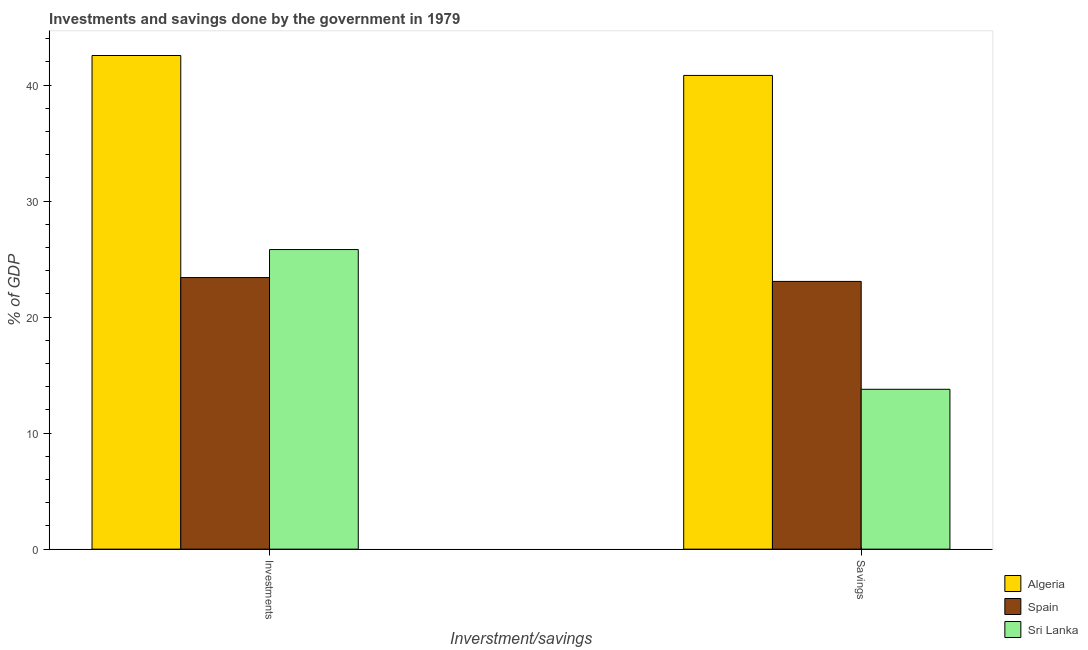How many different coloured bars are there?
Your answer should be very brief. 3. Are the number of bars per tick equal to the number of legend labels?
Offer a very short reply. Yes. How many bars are there on the 2nd tick from the left?
Make the answer very short. 3. What is the label of the 2nd group of bars from the left?
Make the answer very short. Savings. What is the investments of government in Spain?
Make the answer very short. 23.41. Across all countries, what is the maximum savings of government?
Your answer should be very brief. 40.83. Across all countries, what is the minimum savings of government?
Offer a very short reply. 13.78. In which country was the savings of government maximum?
Offer a very short reply. Algeria. In which country was the savings of government minimum?
Provide a short and direct response. Sri Lanka. What is the total savings of government in the graph?
Offer a terse response. 77.68. What is the difference between the savings of government in Spain and that in Algeria?
Give a very brief answer. -17.75. What is the difference between the savings of government in Sri Lanka and the investments of government in Spain?
Provide a short and direct response. -9.63. What is the average investments of government per country?
Offer a very short reply. 30.59. What is the difference between the investments of government and savings of government in Sri Lanka?
Give a very brief answer. 12.04. What is the ratio of the investments of government in Spain to that in Algeria?
Ensure brevity in your answer.  0.55. Is the savings of government in Sri Lanka less than that in Algeria?
Your answer should be very brief. Yes. What does the 3rd bar from the left in Investments represents?
Give a very brief answer. Sri Lanka. What does the 1st bar from the right in Savings represents?
Make the answer very short. Sri Lanka. How many countries are there in the graph?
Offer a very short reply. 3. Are the values on the major ticks of Y-axis written in scientific E-notation?
Keep it short and to the point. No. Does the graph contain grids?
Provide a succinct answer. No. Where does the legend appear in the graph?
Ensure brevity in your answer.  Bottom right. What is the title of the graph?
Your answer should be very brief. Investments and savings done by the government in 1979. What is the label or title of the X-axis?
Your answer should be compact. Inverstment/savings. What is the label or title of the Y-axis?
Keep it short and to the point. % of GDP. What is the % of GDP in Algeria in Investments?
Offer a very short reply. 42.55. What is the % of GDP in Spain in Investments?
Your answer should be compact. 23.41. What is the % of GDP in Sri Lanka in Investments?
Make the answer very short. 25.82. What is the % of GDP of Algeria in Savings?
Your answer should be compact. 40.83. What is the % of GDP of Spain in Savings?
Give a very brief answer. 23.08. What is the % of GDP in Sri Lanka in Savings?
Provide a short and direct response. 13.78. Across all Inverstment/savings, what is the maximum % of GDP in Algeria?
Provide a succinct answer. 42.55. Across all Inverstment/savings, what is the maximum % of GDP in Spain?
Offer a very short reply. 23.41. Across all Inverstment/savings, what is the maximum % of GDP of Sri Lanka?
Provide a short and direct response. 25.82. Across all Inverstment/savings, what is the minimum % of GDP in Algeria?
Your response must be concise. 40.83. Across all Inverstment/savings, what is the minimum % of GDP in Spain?
Offer a terse response. 23.08. Across all Inverstment/savings, what is the minimum % of GDP of Sri Lanka?
Your response must be concise. 13.78. What is the total % of GDP in Algeria in the graph?
Ensure brevity in your answer.  83.37. What is the total % of GDP in Spain in the graph?
Your answer should be very brief. 46.48. What is the total % of GDP of Sri Lanka in the graph?
Make the answer very short. 39.6. What is the difference between the % of GDP of Algeria in Investments and that in Savings?
Offer a terse response. 1.72. What is the difference between the % of GDP in Spain in Investments and that in Savings?
Your response must be concise. 0.33. What is the difference between the % of GDP of Sri Lanka in Investments and that in Savings?
Offer a terse response. 12.04. What is the difference between the % of GDP in Algeria in Investments and the % of GDP in Spain in Savings?
Keep it short and to the point. 19.47. What is the difference between the % of GDP in Algeria in Investments and the % of GDP in Sri Lanka in Savings?
Provide a succinct answer. 28.77. What is the difference between the % of GDP of Spain in Investments and the % of GDP of Sri Lanka in Savings?
Offer a terse response. 9.63. What is the average % of GDP of Algeria per Inverstment/savings?
Make the answer very short. 41.69. What is the average % of GDP of Spain per Inverstment/savings?
Provide a short and direct response. 23.24. What is the average % of GDP in Sri Lanka per Inverstment/savings?
Offer a very short reply. 19.8. What is the difference between the % of GDP of Algeria and % of GDP of Spain in Investments?
Offer a very short reply. 19.14. What is the difference between the % of GDP in Algeria and % of GDP in Sri Lanka in Investments?
Provide a succinct answer. 16.72. What is the difference between the % of GDP in Spain and % of GDP in Sri Lanka in Investments?
Your answer should be compact. -2.41. What is the difference between the % of GDP in Algeria and % of GDP in Spain in Savings?
Your answer should be very brief. 17.75. What is the difference between the % of GDP in Algeria and % of GDP in Sri Lanka in Savings?
Offer a very short reply. 27.05. What is the difference between the % of GDP in Spain and % of GDP in Sri Lanka in Savings?
Make the answer very short. 9.3. What is the ratio of the % of GDP in Algeria in Investments to that in Savings?
Offer a terse response. 1.04. What is the ratio of the % of GDP of Spain in Investments to that in Savings?
Give a very brief answer. 1.01. What is the ratio of the % of GDP in Sri Lanka in Investments to that in Savings?
Provide a short and direct response. 1.87. What is the difference between the highest and the second highest % of GDP of Algeria?
Ensure brevity in your answer.  1.72. What is the difference between the highest and the second highest % of GDP of Spain?
Give a very brief answer. 0.33. What is the difference between the highest and the second highest % of GDP in Sri Lanka?
Ensure brevity in your answer.  12.04. What is the difference between the highest and the lowest % of GDP of Algeria?
Make the answer very short. 1.72. What is the difference between the highest and the lowest % of GDP of Spain?
Keep it short and to the point. 0.33. What is the difference between the highest and the lowest % of GDP in Sri Lanka?
Your response must be concise. 12.04. 